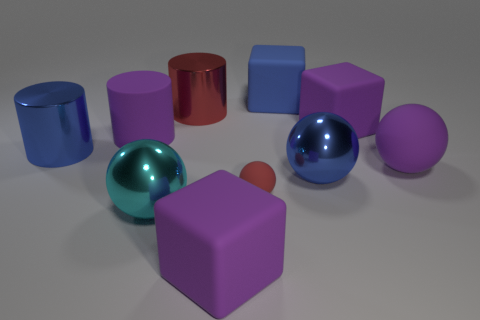There is a sphere that is the same color as the rubber cylinder; what is its size?
Make the answer very short. Large. Is the number of big purple rubber cylinders that are left of the blue shiny cylinder less than the number of large matte objects on the right side of the big red object?
Provide a succinct answer. Yes. Is the material of the big blue block the same as the large purple block to the right of the big blue matte cube?
Your response must be concise. Yes. Is the number of tiny yellow metal cylinders greater than the number of purple cylinders?
Your answer should be compact. No. What is the shape of the red thing that is behind the purple matte ball in front of the metallic cylinder on the right side of the large cyan object?
Make the answer very short. Cylinder. Does the big blue object that is right of the large blue matte object have the same material as the large block to the left of the large blue rubber cube?
Give a very brief answer. No. There is a blue thing that is the same material as the red ball; what is its shape?
Your response must be concise. Cube. How many big blue things are there?
Offer a terse response. 3. What is the material of the large object that is in front of the big ball that is in front of the tiny matte object?
Provide a succinct answer. Rubber. There is a big shiny cylinder on the right side of the big blue object to the left of the purple cube to the left of the blue cube; what is its color?
Offer a terse response. Red. 